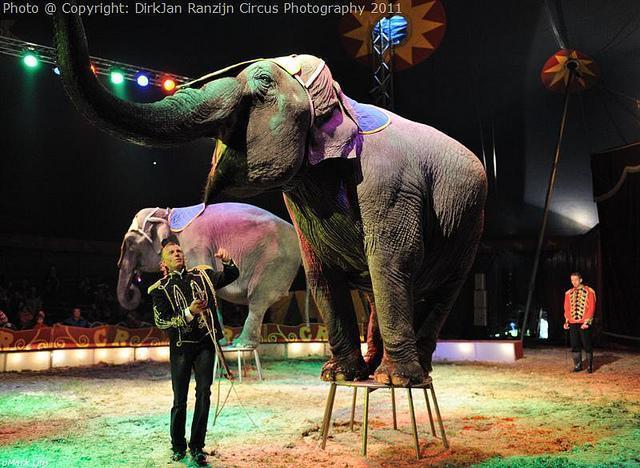How many elephants?
Give a very brief answer. 2. How many elephants are in the photo?
Give a very brief answer. 2. How many bears are wearing hats?
Give a very brief answer. 0. 